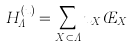<formula> <loc_0><loc_0><loc_500><loc_500>H _ { \Lambda } ^ { ( u ) } = \sum _ { X \subset \Lambda } u _ { X } \phi _ { X }</formula> 